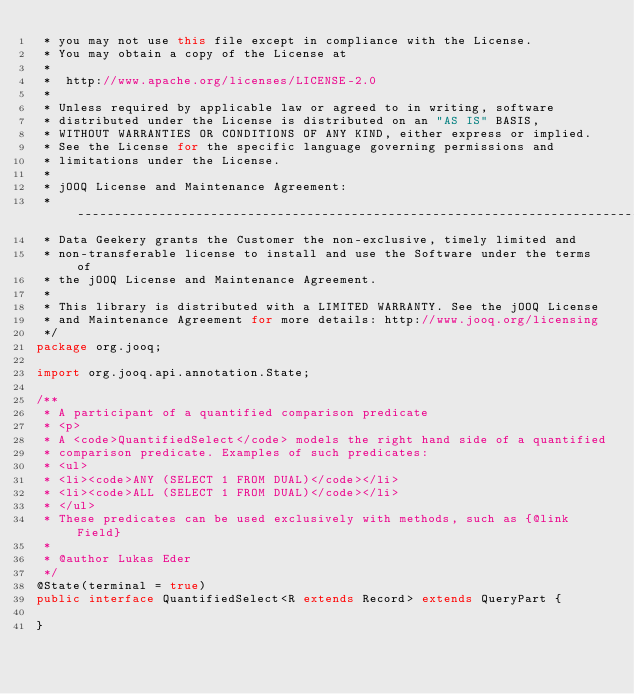Convert code to text. <code><loc_0><loc_0><loc_500><loc_500><_Java_> * you may not use this file except in compliance with the License.
 * You may obtain a copy of the License at
 *
 *  http://www.apache.org/licenses/LICENSE-2.0
 *
 * Unless required by applicable law or agreed to in writing, software
 * distributed under the License is distributed on an "AS IS" BASIS,
 * WITHOUT WARRANTIES OR CONDITIONS OF ANY KIND, either express or implied.
 * See the License for the specific language governing permissions and
 * limitations under the License.
 *
 * jOOQ License and Maintenance Agreement:
 * -----------------------------------------------------------------------------
 * Data Geekery grants the Customer the non-exclusive, timely limited and
 * non-transferable license to install and use the Software under the terms of
 * the jOOQ License and Maintenance Agreement.
 *
 * This library is distributed with a LIMITED WARRANTY. See the jOOQ License
 * and Maintenance Agreement for more details: http://www.jooq.org/licensing
 */
package org.jooq;

import org.jooq.api.annotation.State;

/**
 * A participant of a quantified comparison predicate
 * <p>
 * A <code>QuantifiedSelect</code> models the right hand side of a quantified
 * comparison predicate. Examples of such predicates:
 * <ul>
 * <li><code>ANY (SELECT 1 FROM DUAL)</code></li>
 * <li><code>ALL (SELECT 1 FROM DUAL)</code></li>
 * </ul>
 * These predicates can be used exclusively with methods, such as {@link Field}
 *
 * @author Lukas Eder
 */
@State(terminal = true)
public interface QuantifiedSelect<R extends Record> extends QueryPart {

}
</code> 